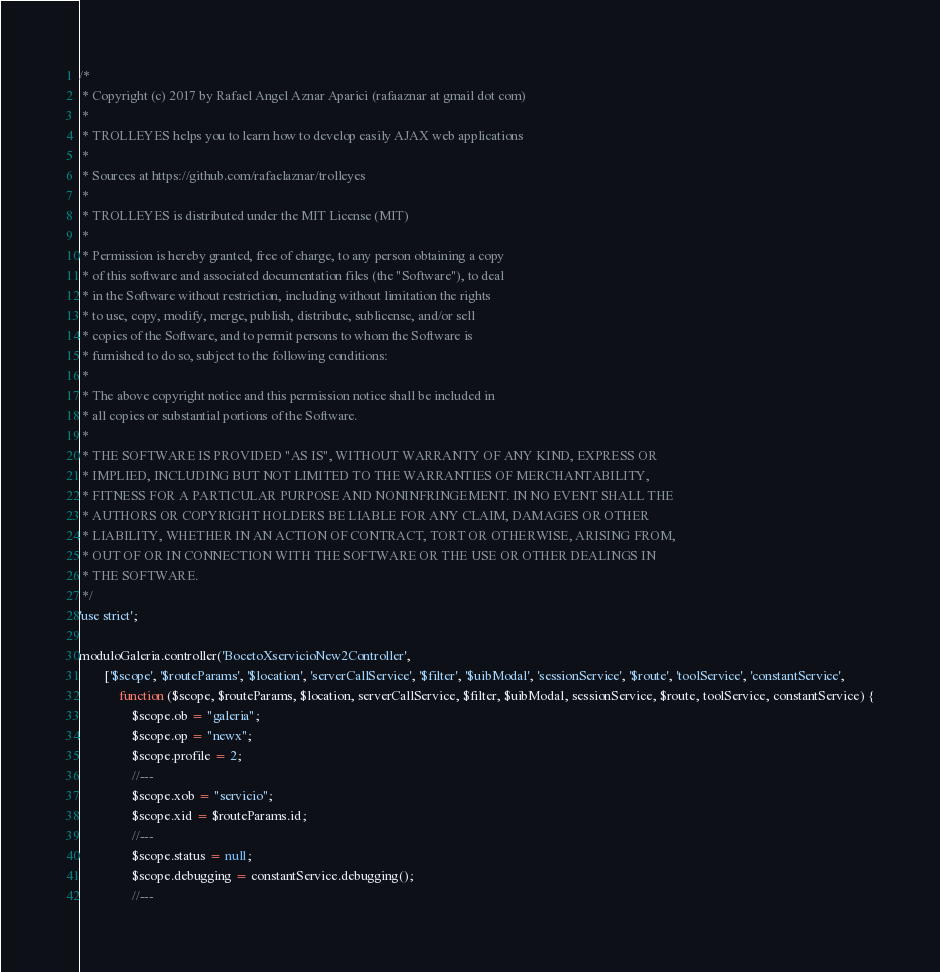<code> <loc_0><loc_0><loc_500><loc_500><_JavaScript_>/*
 * Copyright (c) 2017 by Rafael Angel Aznar Aparici (rafaaznar at gmail dot com)
 *
 * TROLLEYES helps you to learn how to develop easily AJAX web applications
 *
 * Sources at https://github.com/rafaelaznar/trolleyes
 *
 * TROLLEYES is distributed under the MIT License (MIT)
 *
 * Permission is hereby granted, free of charge, to any person obtaining a copy
 * of this software and associated documentation files (the "Software"), to deal
 * in the Software without restriction, including without limitation the rights
 * to use, copy, modify, merge, publish, distribute, sublicense, and/or sell
 * copies of the Software, and to permit persons to whom the Software is
 * furnished to do so, subject to the following conditions:
 *
 * The above copyright notice and this permission notice shall be included in
 * all copies or substantial portions of the Software.
 *
 * THE SOFTWARE IS PROVIDED "AS IS", WITHOUT WARRANTY OF ANY KIND, EXPRESS OR
 * IMPLIED, INCLUDING BUT NOT LIMITED TO THE WARRANTIES OF MERCHANTABILITY,
 * FITNESS FOR A PARTICULAR PURPOSE AND NONINFRINGEMENT. IN NO EVENT SHALL THE
 * AUTHORS OR COPYRIGHT HOLDERS BE LIABLE FOR ANY CLAIM, DAMAGES OR OTHER
 * LIABILITY, WHETHER IN AN ACTION OF CONTRACT, TORT OR OTHERWISE, ARISING FROM,
 * OUT OF OR IN CONNECTION WITH THE SOFTWARE OR THE USE OR OTHER DEALINGS IN
 * THE SOFTWARE.
 */
'use strict';

moduloGaleria.controller('BocetoXservicioNew2Controller',
        ['$scope', '$routeParams', '$location', 'serverCallService', '$filter', '$uibModal', 'sessionService', '$route', 'toolService', 'constantService',
            function ($scope, $routeParams, $location, serverCallService, $filter, $uibModal, sessionService, $route, toolService, constantService) {
                $scope.ob = "galeria";
                $scope.op = "newx";
                $scope.profile = 2;
                //---
                $scope.xob = "servicio";
                $scope.xid = $routeParams.id;
                //---
                $scope.status = null;
                $scope.debugging = constantService.debugging();
                //---</code> 